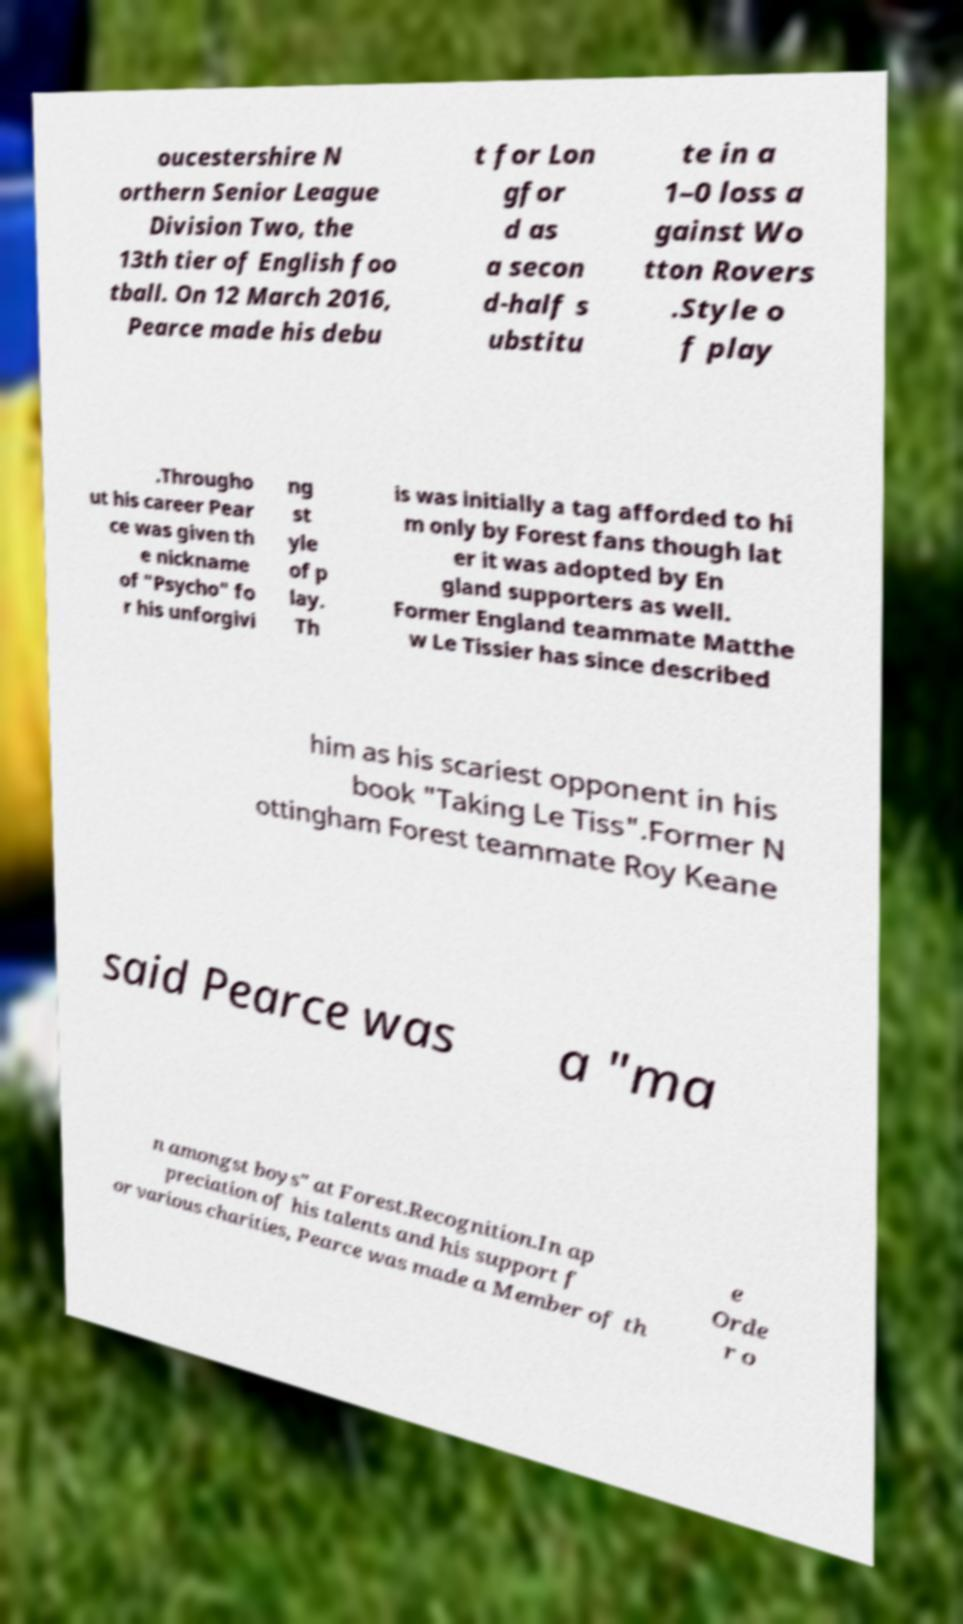I need the written content from this picture converted into text. Can you do that? oucestershire N orthern Senior League Division Two, the 13th tier of English foo tball. On 12 March 2016, Pearce made his debu t for Lon gfor d as a secon d-half s ubstitu te in a 1–0 loss a gainst Wo tton Rovers .Style o f play .Througho ut his career Pear ce was given th e nickname of "Psycho" fo r his unforgivi ng st yle of p lay. Th is was initially a tag afforded to hi m only by Forest fans though lat er it was adopted by En gland supporters as well. Former England teammate Matthe w Le Tissier has since described him as his scariest opponent in his book "Taking Le Tiss".Former N ottingham Forest teammate Roy Keane said Pearce was a "ma n amongst boys" at Forest.Recognition.In ap preciation of his talents and his support f or various charities, Pearce was made a Member of th e Orde r o 